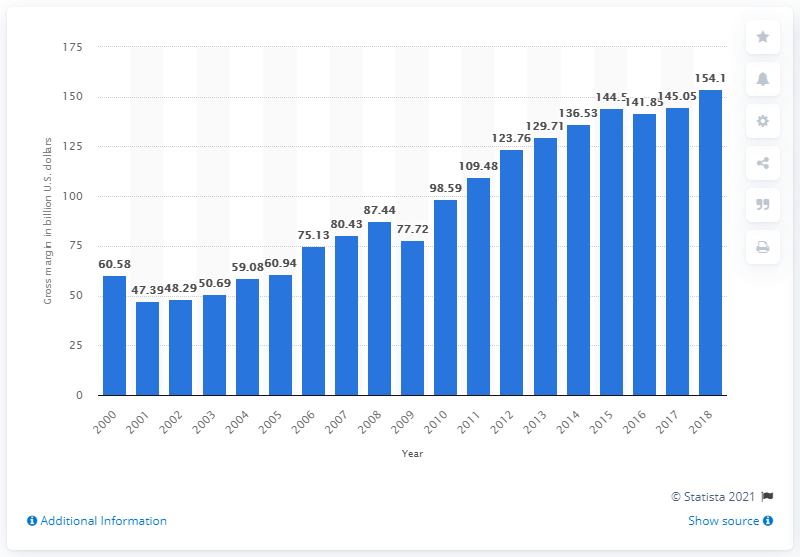Indicate a few pertinent items in this graphic. In 2018, the gross margin on household appliances and electrical and electronic goods in U.S. wholesale was 154.1%. This indicates that the revenue earned on these products, after deducting the cost of goods sold, was 154.1% of their value. 